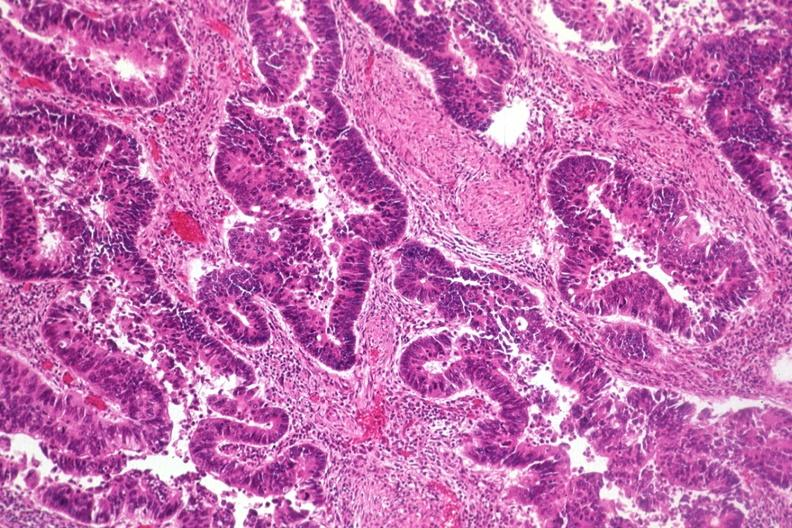does this image show typical histology for colon adenocarcinoma?
Answer the question using a single word or phrase. Yes 